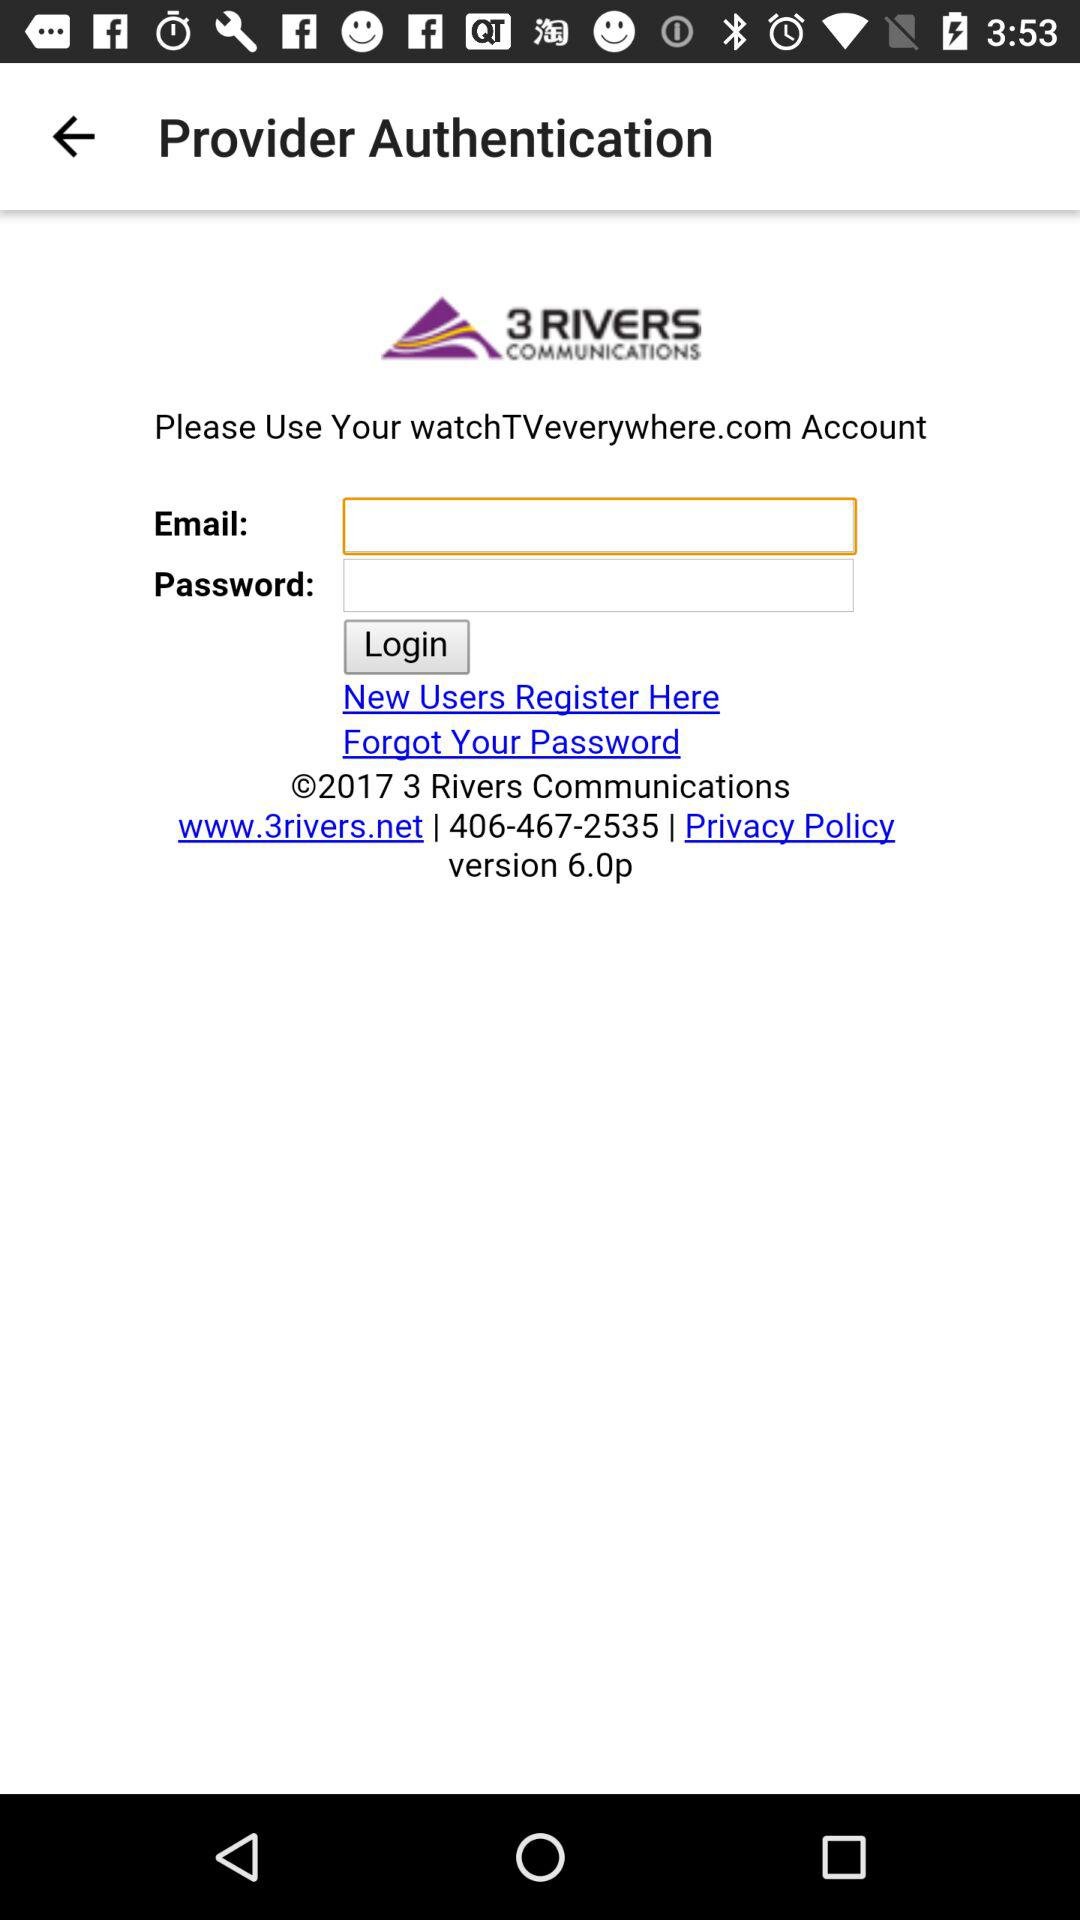What is the name of the application? The name of the application is "3 Rivers Smart Home". 